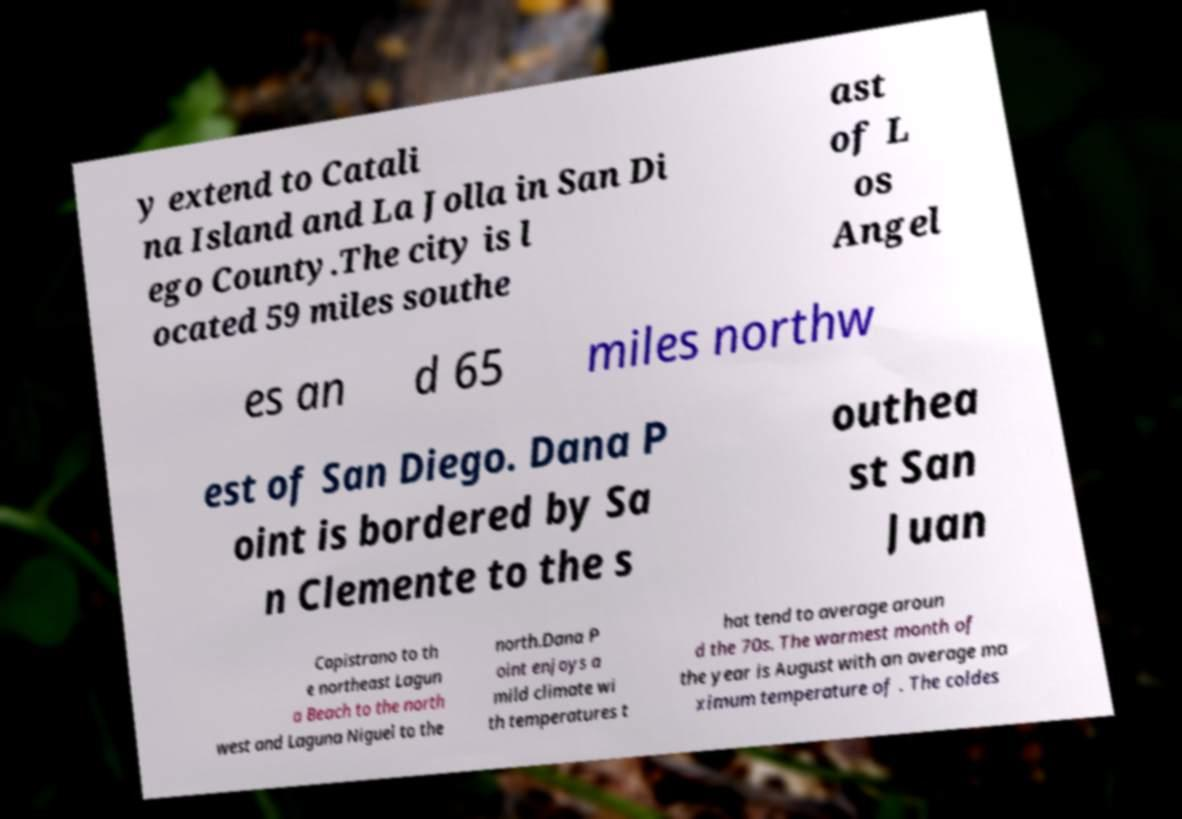Could you extract and type out the text from this image? y extend to Catali na Island and La Jolla in San Di ego County.The city is l ocated 59 miles southe ast of L os Angel es an d 65 miles northw est of San Diego. Dana P oint is bordered by Sa n Clemente to the s outhea st San Juan Capistrano to th e northeast Lagun a Beach to the north west and Laguna Niguel to the north.Dana P oint enjoys a mild climate wi th temperatures t hat tend to average aroun d the 70s. The warmest month of the year is August with an average ma ximum temperature of . The coldes 